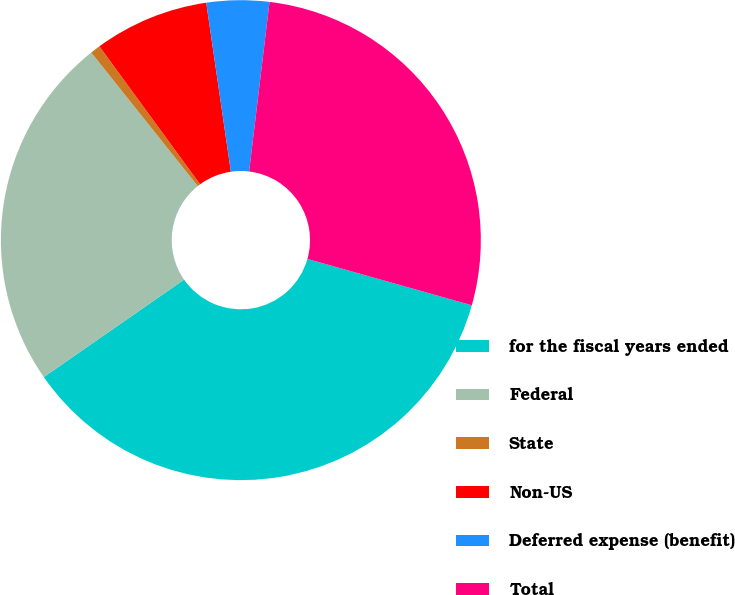Convert chart. <chart><loc_0><loc_0><loc_500><loc_500><pie_chart><fcel>for the fiscal years ended<fcel>Federal<fcel>State<fcel>Non-US<fcel>Deferred expense (benefit)<fcel>Total<nl><fcel>35.96%<fcel>23.95%<fcel>0.68%<fcel>7.73%<fcel>4.21%<fcel>27.47%<nl></chart> 